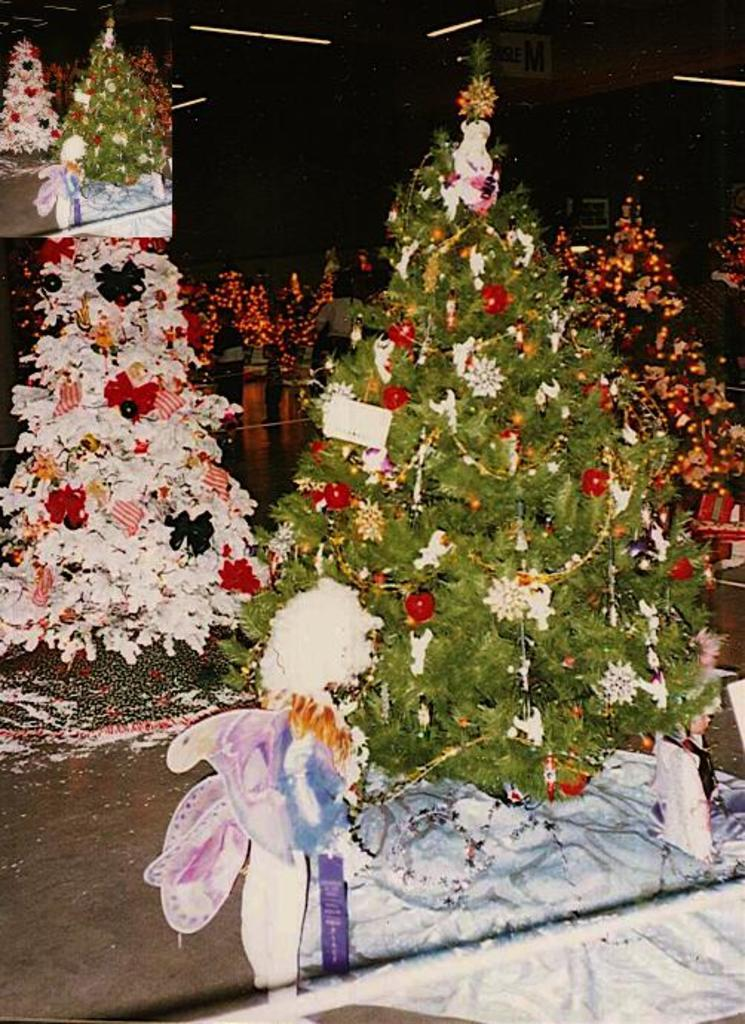What type of decorations are present in the image? There are Christmas trees in the image. What other objects can be seen in the image? There is a toy and lights visible in the image. What surface is present in the image? There is a board in the image. How would you describe the lighting in the image? The background of the image is dark. What type of lipstick is the secretary wearing in the image? There is no secretary or lipstick present in the image. Can you describe the earrings the person in the image is wearing? There is no person or earrings present in the image. 